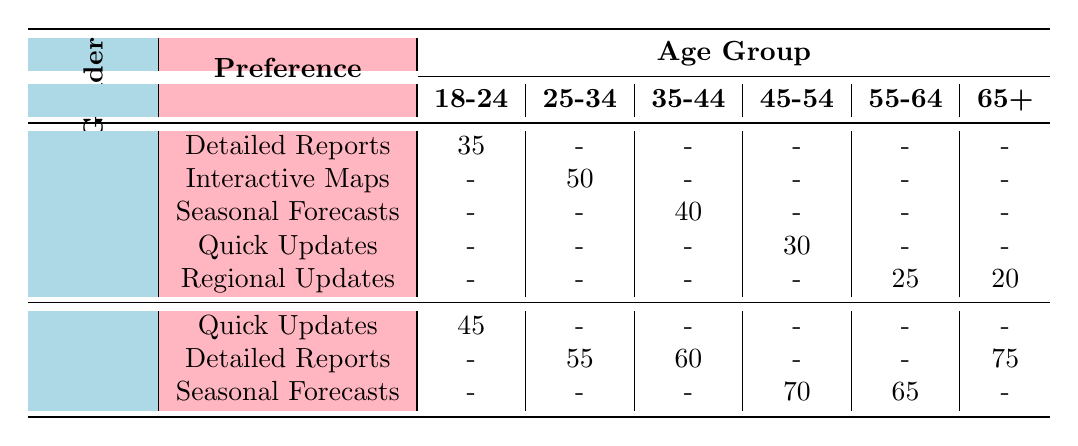What is the frequency of males aged 18-24 who prefer Detailed Reports? The table shows that under the Male gender in the 18-24 age group, the frequency for Detailed Reports is 35.
Answer: 35 What is the most common preference for females aged 65 and older? For females aged 65+, the table indicates that the preference with the highest frequency is Detailed Reports at 75.
Answer: Detailed Reports How many females prefer Quick Updates across all age groups? The table lists females preferring Quick Updates only in the 18-24 age group with a frequency of 45. Summing gives 45.
Answer: 45 Which gender has the highest frequency preference for Seasonal Forecasts in the 45-54 age group? Males have a frequency of 0 and females have a frequency of 70 in the 45-54 age group. Therefore, females have the highest preference.
Answer: Female What is the average frequency of males across all age groups? Adding up the frequencies for males: 35 + 50 + 40 + 30 + 25 + 20 = 200. There are 6 data points, so the average is 200/6 ≈ 33.33.
Answer: Approximately 33.33 Is there any age group where males prefer Quick Updates? The table shows that males aged 45-54 prefer Quick Updates, while all other age groups either have no male preferences or different types, confirming that yes, there is.
Answer: Yes Which age group has the least preference for Regional Updates among males? Males aged 55-64 have a frequency of 25 and those aged 65+ have a frequency of 20 for Regional Updates. The lower frequency is for the 65+ age group.
Answer: 65+ How does the preference for Detailed Reports vary between males and females aged 35-44? In the 35-44 age group, males have 40 for Seasonal Forecasts, while females have 60 for Detailed Reports, showing that females prefer Detailed Reports more.
Answer: Females prefer more What is the total frequency of preferences for Seasonal Forecasts across all age groups for females? In the table, female frequencies for Seasonal Forecasts are 70 (45-54) + 65 (55-64) = 135. This gives us the total frequency across the relevant age groups.
Answer: 135 Are there any preferences for Interactive Maps among females? The table shows that only males in the 25-34 age group have a frequency of 50 for Interactive Maps, confirming that no females prefer it.
Answer: No 